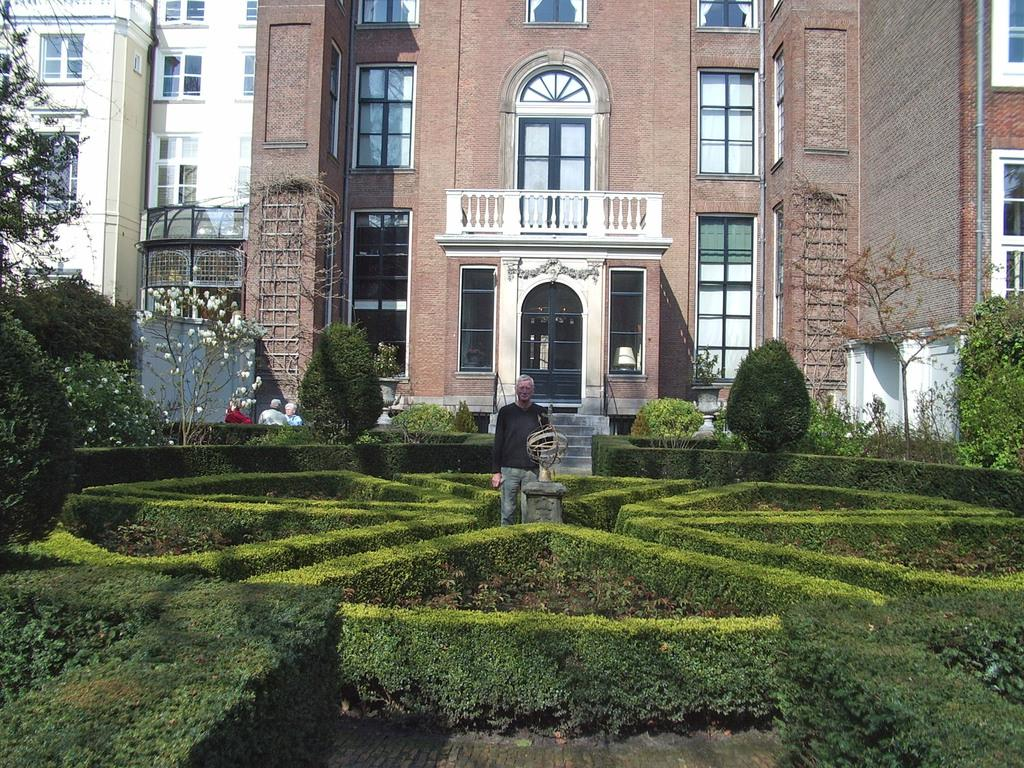What is the main subject of the image? There is a person standing near a fountain. What type of vegetation can be seen in the image? There are plants, trees, and flowers visible in the image. What can be seen in the background of the image? There are buildings visible in the background of the image. How many chickens are present in the image? There are no chickens present in the image. What advice does the person's grandfather give them in the image? There is no mention of a grandfather or any advice in the image. 